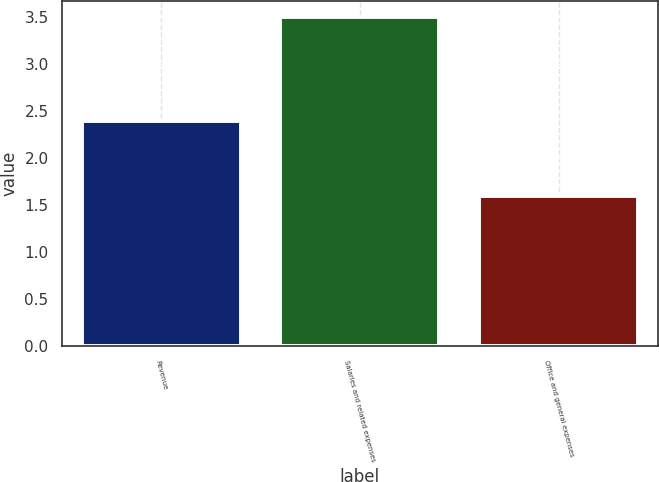Convert chart. <chart><loc_0><loc_0><loc_500><loc_500><bar_chart><fcel>Revenue<fcel>Salaries and related expenses<fcel>Office and general expenses<nl><fcel>2.4<fcel>3.5<fcel>1.6<nl></chart> 